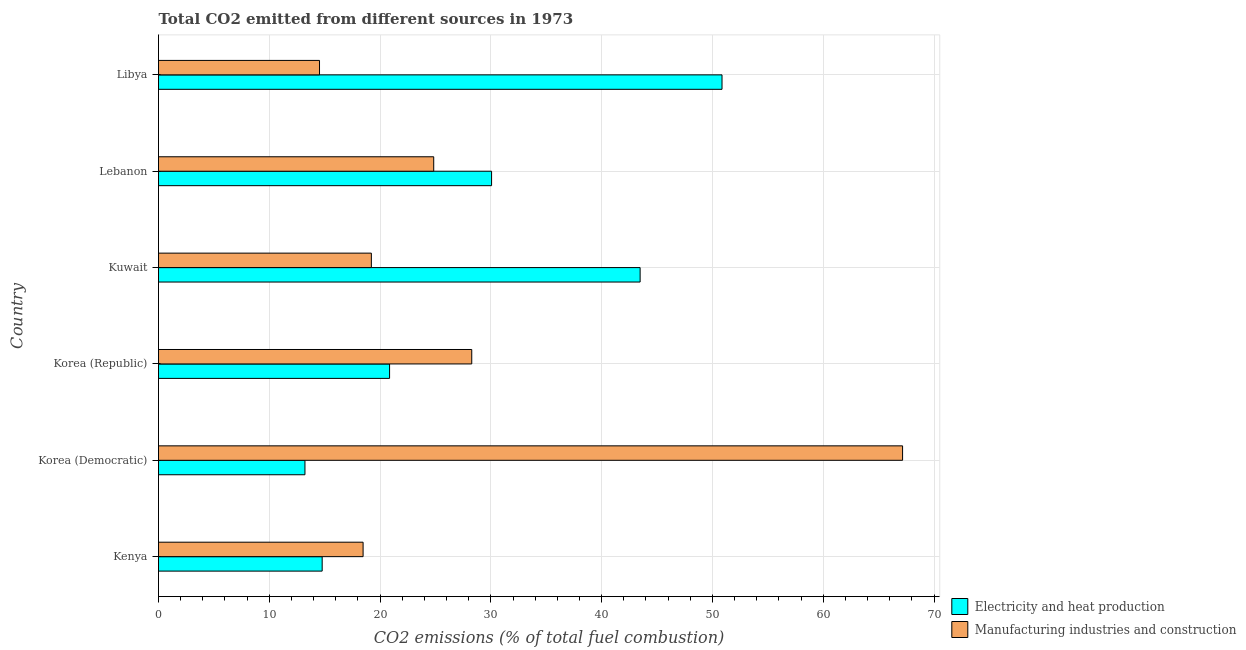How many different coloured bars are there?
Offer a terse response. 2. How many groups of bars are there?
Give a very brief answer. 6. What is the label of the 5th group of bars from the top?
Ensure brevity in your answer.  Korea (Democratic). In how many cases, is the number of bars for a given country not equal to the number of legend labels?
Your response must be concise. 0. What is the co2 emissions due to manufacturing industries in Korea (Republic)?
Your answer should be very brief. 28.27. Across all countries, what is the maximum co2 emissions due to manufacturing industries?
Make the answer very short. 67.16. Across all countries, what is the minimum co2 emissions due to electricity and heat production?
Keep it short and to the point. 13.22. In which country was the co2 emissions due to manufacturing industries maximum?
Offer a terse response. Korea (Democratic). In which country was the co2 emissions due to electricity and heat production minimum?
Ensure brevity in your answer.  Korea (Democratic). What is the total co2 emissions due to electricity and heat production in the graph?
Your response must be concise. 173.25. What is the difference between the co2 emissions due to manufacturing industries in Korea (Democratic) and that in Lebanon?
Ensure brevity in your answer.  42.32. What is the difference between the co2 emissions due to manufacturing industries in Libya and the co2 emissions due to electricity and heat production in Lebanon?
Make the answer very short. -15.53. What is the average co2 emissions due to manufacturing industries per country?
Your answer should be compact. 28.75. What is the difference between the co2 emissions due to manufacturing industries and co2 emissions due to electricity and heat production in Korea (Republic)?
Offer a very short reply. 7.42. In how many countries, is the co2 emissions due to manufacturing industries greater than 2 %?
Provide a succinct answer. 6. What is the ratio of the co2 emissions due to manufacturing industries in Kenya to that in Korea (Republic)?
Provide a succinct answer. 0.65. What is the difference between the highest and the second highest co2 emissions due to electricity and heat production?
Provide a succinct answer. 7.39. What is the difference between the highest and the lowest co2 emissions due to electricity and heat production?
Provide a succinct answer. 37.65. What does the 2nd bar from the top in Libya represents?
Provide a short and direct response. Electricity and heat production. What does the 2nd bar from the bottom in Korea (Democratic) represents?
Keep it short and to the point. Manufacturing industries and construction. How many bars are there?
Make the answer very short. 12. How many countries are there in the graph?
Keep it short and to the point. 6. What is the difference between two consecutive major ticks on the X-axis?
Your answer should be compact. 10. How are the legend labels stacked?
Offer a very short reply. Vertical. What is the title of the graph?
Keep it short and to the point. Total CO2 emitted from different sources in 1973. What is the label or title of the X-axis?
Your answer should be very brief. CO2 emissions (% of total fuel combustion). What is the label or title of the Y-axis?
Your answer should be very brief. Country. What is the CO2 emissions (% of total fuel combustion) in Electricity and heat production in Kenya?
Your answer should be very brief. 14.77. What is the CO2 emissions (% of total fuel combustion) of Manufacturing industries and construction in Kenya?
Ensure brevity in your answer.  18.47. What is the CO2 emissions (% of total fuel combustion) in Electricity and heat production in Korea (Democratic)?
Your answer should be very brief. 13.22. What is the CO2 emissions (% of total fuel combustion) in Manufacturing industries and construction in Korea (Democratic)?
Your response must be concise. 67.16. What is the CO2 emissions (% of total fuel combustion) in Electricity and heat production in Korea (Republic)?
Your answer should be very brief. 20.86. What is the CO2 emissions (% of total fuel combustion) of Manufacturing industries and construction in Korea (Republic)?
Give a very brief answer. 28.27. What is the CO2 emissions (% of total fuel combustion) of Electricity and heat production in Kuwait?
Keep it short and to the point. 43.47. What is the CO2 emissions (% of total fuel combustion) of Manufacturing industries and construction in Kuwait?
Make the answer very short. 19.21. What is the CO2 emissions (% of total fuel combustion) in Electricity and heat production in Lebanon?
Your response must be concise. 30.06. What is the CO2 emissions (% of total fuel combustion) of Manufacturing industries and construction in Lebanon?
Give a very brief answer. 24.84. What is the CO2 emissions (% of total fuel combustion) of Electricity and heat production in Libya?
Your answer should be very brief. 50.87. What is the CO2 emissions (% of total fuel combustion) in Manufacturing industries and construction in Libya?
Ensure brevity in your answer.  14.53. Across all countries, what is the maximum CO2 emissions (% of total fuel combustion) in Electricity and heat production?
Make the answer very short. 50.87. Across all countries, what is the maximum CO2 emissions (% of total fuel combustion) in Manufacturing industries and construction?
Offer a very short reply. 67.16. Across all countries, what is the minimum CO2 emissions (% of total fuel combustion) of Electricity and heat production?
Keep it short and to the point. 13.22. Across all countries, what is the minimum CO2 emissions (% of total fuel combustion) in Manufacturing industries and construction?
Keep it short and to the point. 14.53. What is the total CO2 emissions (% of total fuel combustion) of Electricity and heat production in the graph?
Your answer should be compact. 173.25. What is the total CO2 emissions (% of total fuel combustion) in Manufacturing industries and construction in the graph?
Provide a succinct answer. 172.49. What is the difference between the CO2 emissions (% of total fuel combustion) in Electricity and heat production in Kenya and that in Korea (Democratic)?
Your answer should be very brief. 1.55. What is the difference between the CO2 emissions (% of total fuel combustion) of Manufacturing industries and construction in Kenya and that in Korea (Democratic)?
Ensure brevity in your answer.  -48.7. What is the difference between the CO2 emissions (% of total fuel combustion) of Electricity and heat production in Kenya and that in Korea (Republic)?
Keep it short and to the point. -6.08. What is the difference between the CO2 emissions (% of total fuel combustion) of Manufacturing industries and construction in Kenya and that in Korea (Republic)?
Offer a terse response. -9.81. What is the difference between the CO2 emissions (% of total fuel combustion) in Electricity and heat production in Kenya and that in Kuwait?
Your response must be concise. -28.7. What is the difference between the CO2 emissions (% of total fuel combustion) in Manufacturing industries and construction in Kenya and that in Kuwait?
Offer a terse response. -0.75. What is the difference between the CO2 emissions (% of total fuel combustion) in Electricity and heat production in Kenya and that in Lebanon?
Offer a very short reply. -15.29. What is the difference between the CO2 emissions (% of total fuel combustion) of Manufacturing industries and construction in Kenya and that in Lebanon?
Make the answer very short. -6.38. What is the difference between the CO2 emissions (% of total fuel combustion) in Electricity and heat production in Kenya and that in Libya?
Make the answer very short. -36.09. What is the difference between the CO2 emissions (% of total fuel combustion) of Manufacturing industries and construction in Kenya and that in Libya?
Provide a short and direct response. 3.93. What is the difference between the CO2 emissions (% of total fuel combustion) in Electricity and heat production in Korea (Democratic) and that in Korea (Republic)?
Keep it short and to the point. -7.64. What is the difference between the CO2 emissions (% of total fuel combustion) in Manufacturing industries and construction in Korea (Democratic) and that in Korea (Republic)?
Give a very brief answer. 38.89. What is the difference between the CO2 emissions (% of total fuel combustion) in Electricity and heat production in Korea (Democratic) and that in Kuwait?
Give a very brief answer. -30.25. What is the difference between the CO2 emissions (% of total fuel combustion) of Manufacturing industries and construction in Korea (Democratic) and that in Kuwait?
Provide a succinct answer. 47.95. What is the difference between the CO2 emissions (% of total fuel combustion) of Electricity and heat production in Korea (Democratic) and that in Lebanon?
Your response must be concise. -16.84. What is the difference between the CO2 emissions (% of total fuel combustion) of Manufacturing industries and construction in Korea (Democratic) and that in Lebanon?
Offer a very short reply. 42.32. What is the difference between the CO2 emissions (% of total fuel combustion) of Electricity and heat production in Korea (Democratic) and that in Libya?
Keep it short and to the point. -37.65. What is the difference between the CO2 emissions (% of total fuel combustion) of Manufacturing industries and construction in Korea (Democratic) and that in Libya?
Give a very brief answer. 52.63. What is the difference between the CO2 emissions (% of total fuel combustion) in Electricity and heat production in Korea (Republic) and that in Kuwait?
Offer a terse response. -22.62. What is the difference between the CO2 emissions (% of total fuel combustion) of Manufacturing industries and construction in Korea (Republic) and that in Kuwait?
Ensure brevity in your answer.  9.06. What is the difference between the CO2 emissions (% of total fuel combustion) of Electricity and heat production in Korea (Republic) and that in Lebanon?
Give a very brief answer. -9.21. What is the difference between the CO2 emissions (% of total fuel combustion) of Manufacturing industries and construction in Korea (Republic) and that in Lebanon?
Ensure brevity in your answer.  3.43. What is the difference between the CO2 emissions (% of total fuel combustion) of Electricity and heat production in Korea (Republic) and that in Libya?
Provide a succinct answer. -30.01. What is the difference between the CO2 emissions (% of total fuel combustion) of Manufacturing industries and construction in Korea (Republic) and that in Libya?
Ensure brevity in your answer.  13.74. What is the difference between the CO2 emissions (% of total fuel combustion) in Electricity and heat production in Kuwait and that in Lebanon?
Your response must be concise. 13.41. What is the difference between the CO2 emissions (% of total fuel combustion) in Manufacturing industries and construction in Kuwait and that in Lebanon?
Your answer should be compact. -5.63. What is the difference between the CO2 emissions (% of total fuel combustion) in Electricity and heat production in Kuwait and that in Libya?
Keep it short and to the point. -7.39. What is the difference between the CO2 emissions (% of total fuel combustion) in Manufacturing industries and construction in Kuwait and that in Libya?
Ensure brevity in your answer.  4.68. What is the difference between the CO2 emissions (% of total fuel combustion) of Electricity and heat production in Lebanon and that in Libya?
Give a very brief answer. -20.8. What is the difference between the CO2 emissions (% of total fuel combustion) of Manufacturing industries and construction in Lebanon and that in Libya?
Offer a terse response. 10.31. What is the difference between the CO2 emissions (% of total fuel combustion) in Electricity and heat production in Kenya and the CO2 emissions (% of total fuel combustion) in Manufacturing industries and construction in Korea (Democratic)?
Provide a short and direct response. -52.39. What is the difference between the CO2 emissions (% of total fuel combustion) in Electricity and heat production in Kenya and the CO2 emissions (% of total fuel combustion) in Manufacturing industries and construction in Korea (Republic)?
Offer a very short reply. -13.5. What is the difference between the CO2 emissions (% of total fuel combustion) of Electricity and heat production in Kenya and the CO2 emissions (% of total fuel combustion) of Manufacturing industries and construction in Kuwait?
Your answer should be very brief. -4.44. What is the difference between the CO2 emissions (% of total fuel combustion) of Electricity and heat production in Kenya and the CO2 emissions (% of total fuel combustion) of Manufacturing industries and construction in Lebanon?
Your response must be concise. -10.07. What is the difference between the CO2 emissions (% of total fuel combustion) in Electricity and heat production in Kenya and the CO2 emissions (% of total fuel combustion) in Manufacturing industries and construction in Libya?
Offer a very short reply. 0.24. What is the difference between the CO2 emissions (% of total fuel combustion) in Electricity and heat production in Korea (Democratic) and the CO2 emissions (% of total fuel combustion) in Manufacturing industries and construction in Korea (Republic)?
Provide a succinct answer. -15.06. What is the difference between the CO2 emissions (% of total fuel combustion) of Electricity and heat production in Korea (Democratic) and the CO2 emissions (% of total fuel combustion) of Manufacturing industries and construction in Kuwait?
Give a very brief answer. -5.99. What is the difference between the CO2 emissions (% of total fuel combustion) in Electricity and heat production in Korea (Democratic) and the CO2 emissions (% of total fuel combustion) in Manufacturing industries and construction in Lebanon?
Keep it short and to the point. -11.62. What is the difference between the CO2 emissions (% of total fuel combustion) in Electricity and heat production in Korea (Democratic) and the CO2 emissions (% of total fuel combustion) in Manufacturing industries and construction in Libya?
Provide a short and direct response. -1.31. What is the difference between the CO2 emissions (% of total fuel combustion) of Electricity and heat production in Korea (Republic) and the CO2 emissions (% of total fuel combustion) of Manufacturing industries and construction in Kuwait?
Offer a terse response. 1.64. What is the difference between the CO2 emissions (% of total fuel combustion) of Electricity and heat production in Korea (Republic) and the CO2 emissions (% of total fuel combustion) of Manufacturing industries and construction in Lebanon?
Offer a very short reply. -3.99. What is the difference between the CO2 emissions (% of total fuel combustion) of Electricity and heat production in Korea (Republic) and the CO2 emissions (% of total fuel combustion) of Manufacturing industries and construction in Libya?
Provide a succinct answer. 6.32. What is the difference between the CO2 emissions (% of total fuel combustion) of Electricity and heat production in Kuwait and the CO2 emissions (% of total fuel combustion) of Manufacturing industries and construction in Lebanon?
Your answer should be very brief. 18.63. What is the difference between the CO2 emissions (% of total fuel combustion) in Electricity and heat production in Kuwait and the CO2 emissions (% of total fuel combustion) in Manufacturing industries and construction in Libya?
Your answer should be compact. 28.94. What is the difference between the CO2 emissions (% of total fuel combustion) in Electricity and heat production in Lebanon and the CO2 emissions (% of total fuel combustion) in Manufacturing industries and construction in Libya?
Offer a terse response. 15.53. What is the average CO2 emissions (% of total fuel combustion) of Electricity and heat production per country?
Ensure brevity in your answer.  28.87. What is the average CO2 emissions (% of total fuel combustion) of Manufacturing industries and construction per country?
Make the answer very short. 28.75. What is the difference between the CO2 emissions (% of total fuel combustion) of Electricity and heat production and CO2 emissions (% of total fuel combustion) of Manufacturing industries and construction in Kenya?
Your answer should be compact. -3.69. What is the difference between the CO2 emissions (% of total fuel combustion) of Electricity and heat production and CO2 emissions (% of total fuel combustion) of Manufacturing industries and construction in Korea (Democratic)?
Ensure brevity in your answer.  -53.94. What is the difference between the CO2 emissions (% of total fuel combustion) of Electricity and heat production and CO2 emissions (% of total fuel combustion) of Manufacturing industries and construction in Korea (Republic)?
Your answer should be compact. -7.42. What is the difference between the CO2 emissions (% of total fuel combustion) in Electricity and heat production and CO2 emissions (% of total fuel combustion) in Manufacturing industries and construction in Kuwait?
Ensure brevity in your answer.  24.26. What is the difference between the CO2 emissions (% of total fuel combustion) of Electricity and heat production and CO2 emissions (% of total fuel combustion) of Manufacturing industries and construction in Lebanon?
Make the answer very short. 5.22. What is the difference between the CO2 emissions (% of total fuel combustion) in Electricity and heat production and CO2 emissions (% of total fuel combustion) in Manufacturing industries and construction in Libya?
Your answer should be compact. 36.33. What is the ratio of the CO2 emissions (% of total fuel combustion) of Electricity and heat production in Kenya to that in Korea (Democratic)?
Provide a succinct answer. 1.12. What is the ratio of the CO2 emissions (% of total fuel combustion) of Manufacturing industries and construction in Kenya to that in Korea (Democratic)?
Your answer should be very brief. 0.27. What is the ratio of the CO2 emissions (% of total fuel combustion) of Electricity and heat production in Kenya to that in Korea (Republic)?
Provide a short and direct response. 0.71. What is the ratio of the CO2 emissions (% of total fuel combustion) in Manufacturing industries and construction in Kenya to that in Korea (Republic)?
Provide a short and direct response. 0.65. What is the ratio of the CO2 emissions (% of total fuel combustion) of Electricity and heat production in Kenya to that in Kuwait?
Ensure brevity in your answer.  0.34. What is the ratio of the CO2 emissions (% of total fuel combustion) of Manufacturing industries and construction in Kenya to that in Kuwait?
Your answer should be compact. 0.96. What is the ratio of the CO2 emissions (% of total fuel combustion) of Electricity and heat production in Kenya to that in Lebanon?
Make the answer very short. 0.49. What is the ratio of the CO2 emissions (% of total fuel combustion) of Manufacturing industries and construction in Kenya to that in Lebanon?
Ensure brevity in your answer.  0.74. What is the ratio of the CO2 emissions (% of total fuel combustion) in Electricity and heat production in Kenya to that in Libya?
Offer a very short reply. 0.29. What is the ratio of the CO2 emissions (% of total fuel combustion) of Manufacturing industries and construction in Kenya to that in Libya?
Your response must be concise. 1.27. What is the ratio of the CO2 emissions (% of total fuel combustion) in Electricity and heat production in Korea (Democratic) to that in Korea (Republic)?
Your answer should be compact. 0.63. What is the ratio of the CO2 emissions (% of total fuel combustion) in Manufacturing industries and construction in Korea (Democratic) to that in Korea (Republic)?
Offer a very short reply. 2.38. What is the ratio of the CO2 emissions (% of total fuel combustion) in Electricity and heat production in Korea (Democratic) to that in Kuwait?
Your answer should be compact. 0.3. What is the ratio of the CO2 emissions (% of total fuel combustion) of Manufacturing industries and construction in Korea (Democratic) to that in Kuwait?
Your response must be concise. 3.5. What is the ratio of the CO2 emissions (% of total fuel combustion) in Electricity and heat production in Korea (Democratic) to that in Lebanon?
Make the answer very short. 0.44. What is the ratio of the CO2 emissions (% of total fuel combustion) in Manufacturing industries and construction in Korea (Democratic) to that in Lebanon?
Provide a succinct answer. 2.7. What is the ratio of the CO2 emissions (% of total fuel combustion) of Electricity and heat production in Korea (Democratic) to that in Libya?
Make the answer very short. 0.26. What is the ratio of the CO2 emissions (% of total fuel combustion) in Manufacturing industries and construction in Korea (Democratic) to that in Libya?
Provide a succinct answer. 4.62. What is the ratio of the CO2 emissions (% of total fuel combustion) of Electricity and heat production in Korea (Republic) to that in Kuwait?
Your response must be concise. 0.48. What is the ratio of the CO2 emissions (% of total fuel combustion) in Manufacturing industries and construction in Korea (Republic) to that in Kuwait?
Make the answer very short. 1.47. What is the ratio of the CO2 emissions (% of total fuel combustion) in Electricity and heat production in Korea (Republic) to that in Lebanon?
Offer a very short reply. 0.69. What is the ratio of the CO2 emissions (% of total fuel combustion) of Manufacturing industries and construction in Korea (Republic) to that in Lebanon?
Your answer should be very brief. 1.14. What is the ratio of the CO2 emissions (% of total fuel combustion) of Electricity and heat production in Korea (Republic) to that in Libya?
Your answer should be compact. 0.41. What is the ratio of the CO2 emissions (% of total fuel combustion) of Manufacturing industries and construction in Korea (Republic) to that in Libya?
Ensure brevity in your answer.  1.95. What is the ratio of the CO2 emissions (% of total fuel combustion) in Electricity and heat production in Kuwait to that in Lebanon?
Provide a succinct answer. 1.45. What is the ratio of the CO2 emissions (% of total fuel combustion) in Manufacturing industries and construction in Kuwait to that in Lebanon?
Make the answer very short. 0.77. What is the ratio of the CO2 emissions (% of total fuel combustion) in Electricity and heat production in Kuwait to that in Libya?
Ensure brevity in your answer.  0.85. What is the ratio of the CO2 emissions (% of total fuel combustion) in Manufacturing industries and construction in Kuwait to that in Libya?
Provide a short and direct response. 1.32. What is the ratio of the CO2 emissions (% of total fuel combustion) of Electricity and heat production in Lebanon to that in Libya?
Keep it short and to the point. 0.59. What is the ratio of the CO2 emissions (% of total fuel combustion) in Manufacturing industries and construction in Lebanon to that in Libya?
Make the answer very short. 1.71. What is the difference between the highest and the second highest CO2 emissions (% of total fuel combustion) in Electricity and heat production?
Make the answer very short. 7.39. What is the difference between the highest and the second highest CO2 emissions (% of total fuel combustion) in Manufacturing industries and construction?
Provide a short and direct response. 38.89. What is the difference between the highest and the lowest CO2 emissions (% of total fuel combustion) in Electricity and heat production?
Provide a succinct answer. 37.65. What is the difference between the highest and the lowest CO2 emissions (% of total fuel combustion) of Manufacturing industries and construction?
Provide a short and direct response. 52.63. 